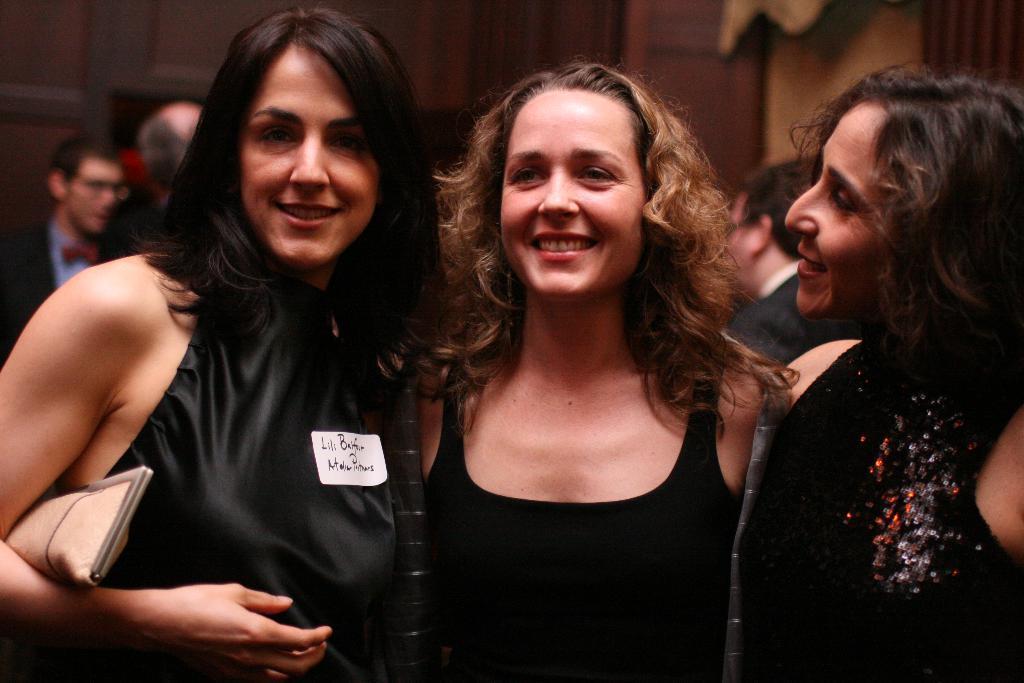Describe this image in one or two sentences. As we can see in the image there are few people here and there and a wall. In the front there are three women wearing black color dresses. 